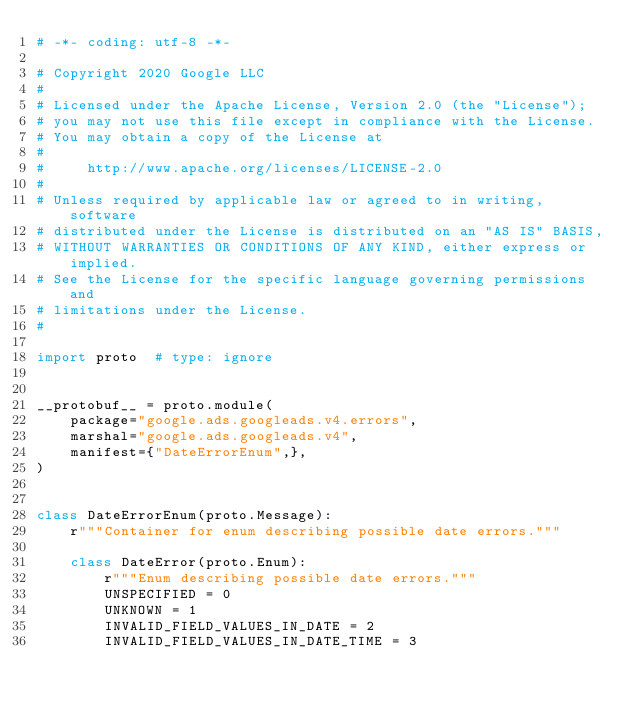<code> <loc_0><loc_0><loc_500><loc_500><_Python_># -*- coding: utf-8 -*-

# Copyright 2020 Google LLC
#
# Licensed under the Apache License, Version 2.0 (the "License");
# you may not use this file except in compliance with the License.
# You may obtain a copy of the License at
#
#     http://www.apache.org/licenses/LICENSE-2.0
#
# Unless required by applicable law or agreed to in writing, software
# distributed under the License is distributed on an "AS IS" BASIS,
# WITHOUT WARRANTIES OR CONDITIONS OF ANY KIND, either express or implied.
# See the License for the specific language governing permissions and
# limitations under the License.
#

import proto  # type: ignore


__protobuf__ = proto.module(
    package="google.ads.googleads.v4.errors",
    marshal="google.ads.googleads.v4",
    manifest={"DateErrorEnum",},
)


class DateErrorEnum(proto.Message):
    r"""Container for enum describing possible date errors."""

    class DateError(proto.Enum):
        r"""Enum describing possible date errors."""
        UNSPECIFIED = 0
        UNKNOWN = 1
        INVALID_FIELD_VALUES_IN_DATE = 2
        INVALID_FIELD_VALUES_IN_DATE_TIME = 3</code> 